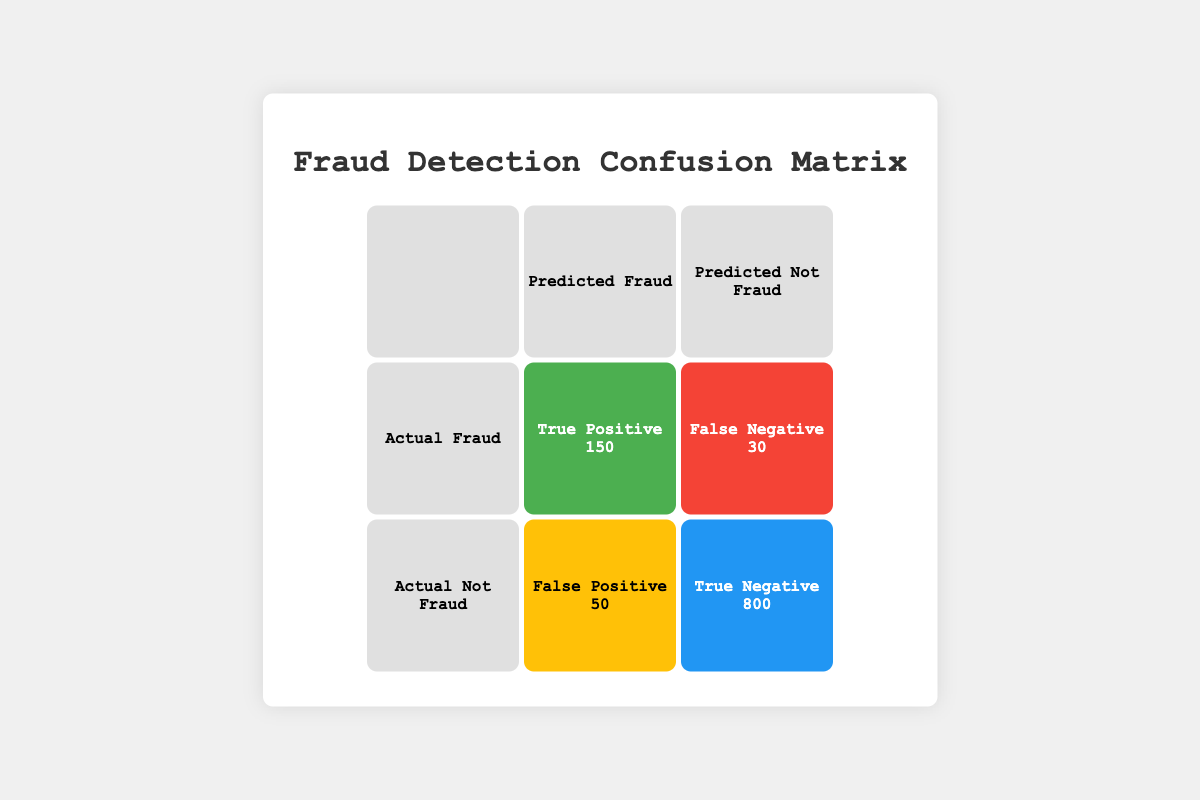What is the value of True Positive in the table? The table shows that the value of True Positive is indicated in the cell where the Actual Fraud row intersects with the Predicted Fraud column. This value is 150.
Answer: 150 How many instances were classified as False Positive? To find the False Positive value, we look at the cell where the Actual Not Fraud row intersects with the Predicted Fraud column, which states the value is 50.
Answer: 50 What is the total number of transactions considered in this confusion matrix? To find the total number of transactions, we add all the values in the confusion matrix: True Positive (150) + False Negative (30) + False Positive (50) + True Negative (800) = 1030.
Answer: 1030 What is the percentage of True Negatives in the total transactions? First, we find the value of True Negatives, which is 800. Then we divide this by the total number of transactions, which we calculated as 1030. So, percentage = (800 / 1030) * 100 = approximately 77.67%.
Answer: 77.67% Is the number of False Negatives greater than the number of False Positives? The table shows the False Negatives are 30 and the False Positives are 50. Since 30 is not greater than 50, the answer is no.
Answer: No How many fraudulent transactions were predicted incorrectly? To find this, we need to look at both types of incorrect predictions. False Negatives (30) and False Positives (50) relate to fraudulent transactions being predicted incorrectly, so we sum these values: 30 + 50 = 80.
Answer: 80 What is the ratio of True Positives to False Negatives? The True Positives are 150 and False Negatives are 30. The ratio is calculated by dividing True Positives by False Negatives: 150 / 30 = 5. This means for every False Negative, there are 5 True Positives.
Answer: 5 What proportion of actual fraudulent transactions were predicted correctly? The actual fraudulent transactions consist of True Positives (150) plus False Negatives (30), which is 180. The proportion predicted correctly is then calculated as True Positives divided by total actual frauds: 150 / 180 = approximately 0.8333, or 83.33%.
Answer: 83.33% 